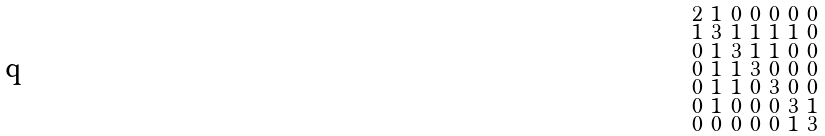Convert formula to latex. <formula><loc_0><loc_0><loc_500><loc_500>\begin{smallmatrix} 2 & 1 & 0 & 0 & 0 & 0 & 0 \\ 1 & 3 & 1 & 1 & 1 & 1 & 0 \\ 0 & 1 & 3 & 1 & 1 & 0 & 0 \\ 0 & 1 & 1 & 3 & 0 & 0 & 0 \\ 0 & 1 & 1 & 0 & 3 & 0 & 0 \\ 0 & 1 & 0 & 0 & 0 & 3 & 1 \\ 0 & 0 & 0 & 0 & 0 & 1 & 3 \end{smallmatrix}</formula> 